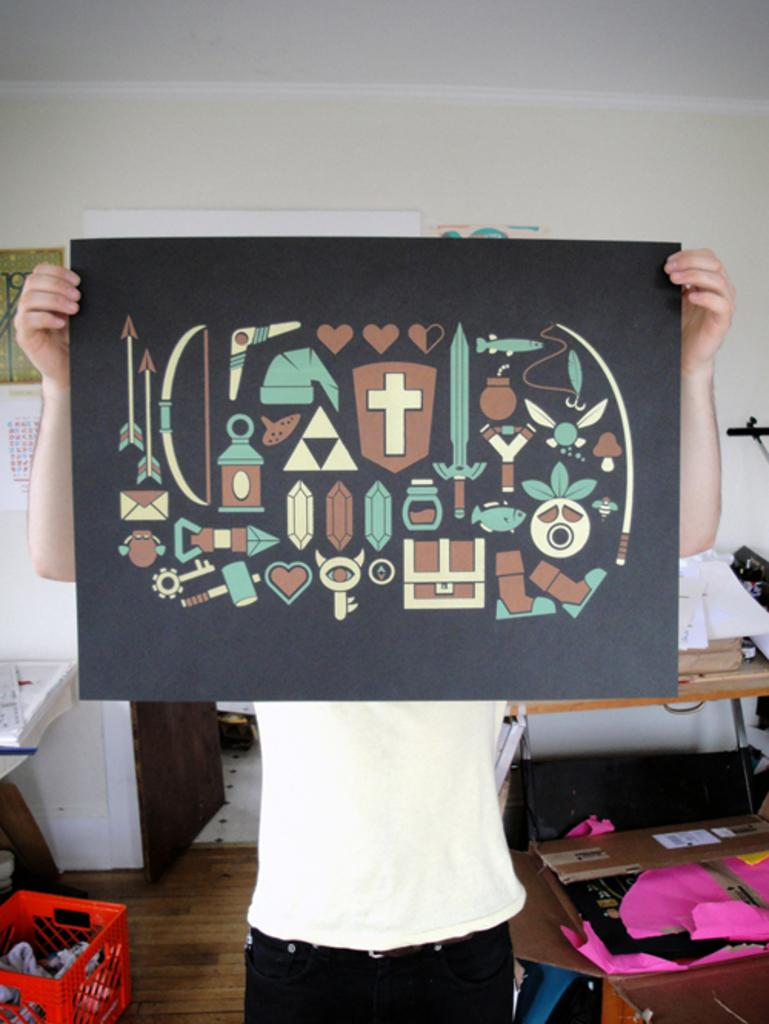What is the person in the image holding? The person is holding a paper with pictures. What can be seen in the background of the image? There are objects in containers, charts, and walls in the background of the image. Can you describe the objects in the containers? Unfortunately, the specific objects in the containers cannot be identified from the provided facts. What might the charts be used for? The charts in the background of the image might be used for displaying information or data. What type of cloud can be seen in the image? There is no cloud present in the image. What is the reason for the person holding the paper with pictures? The reason for the person holding the paper with pictures cannot be determined from the provided facts. 